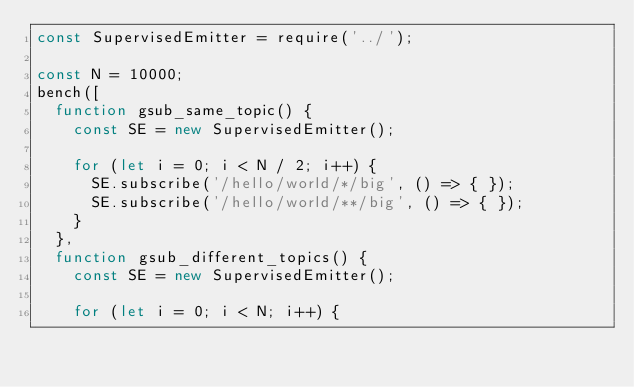Convert code to text. <code><loc_0><loc_0><loc_500><loc_500><_JavaScript_>const SupervisedEmitter = require('../');

const N = 10000;
bench([
  function gsub_same_topic() {
    const SE = new SupervisedEmitter();
    
    for (let i = 0; i < N / 2; i++) {
      SE.subscribe('/hello/world/*/big', () => { });
      SE.subscribe('/hello/world/**/big', () => { });
    }
  },
  function gsub_different_topics() {
    const SE = new SupervisedEmitter();

    for (let i = 0; i < N; i++) {</code> 